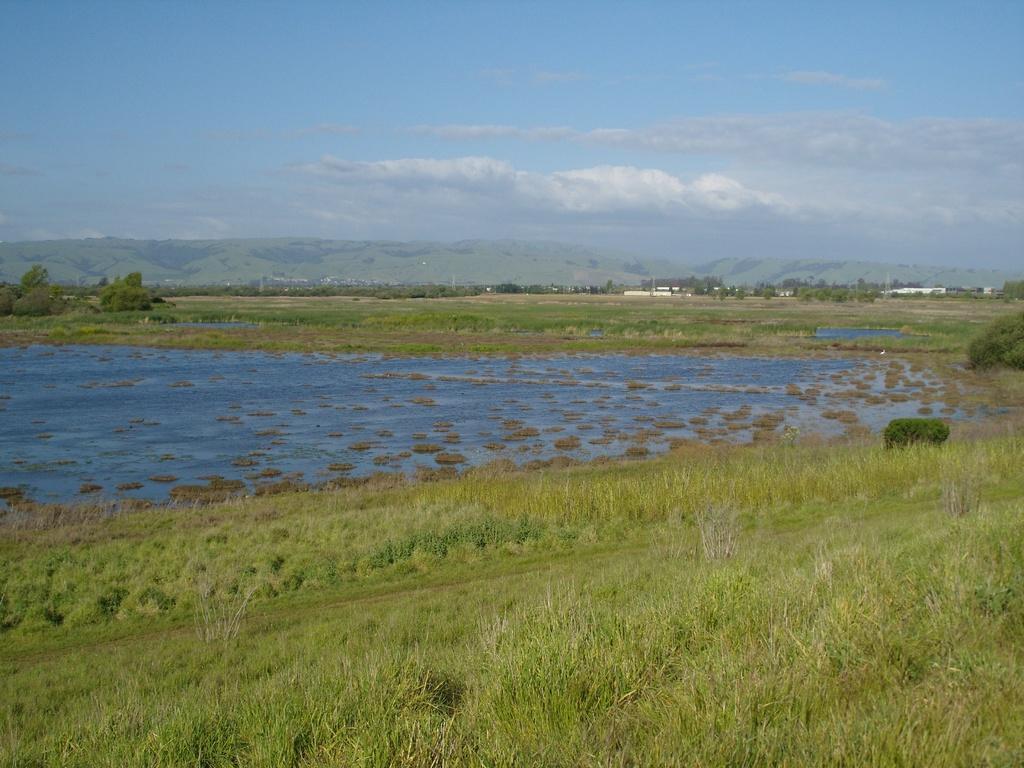In one or two sentences, can you explain what this image depicts? In this image at the bottom there is some grass, and in the center there is a pond. In the background there are mountains, trees, grass and some buildings. At the top of the image there is sky. 